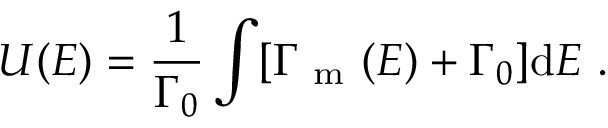Convert formula to latex. <formula><loc_0><loc_0><loc_500><loc_500>U ( E ) = \frac { 1 } { \Gamma _ { 0 } } \int [ \Gamma _ { m } ( E ) + \Gamma _ { 0 } ] d E .</formula> 